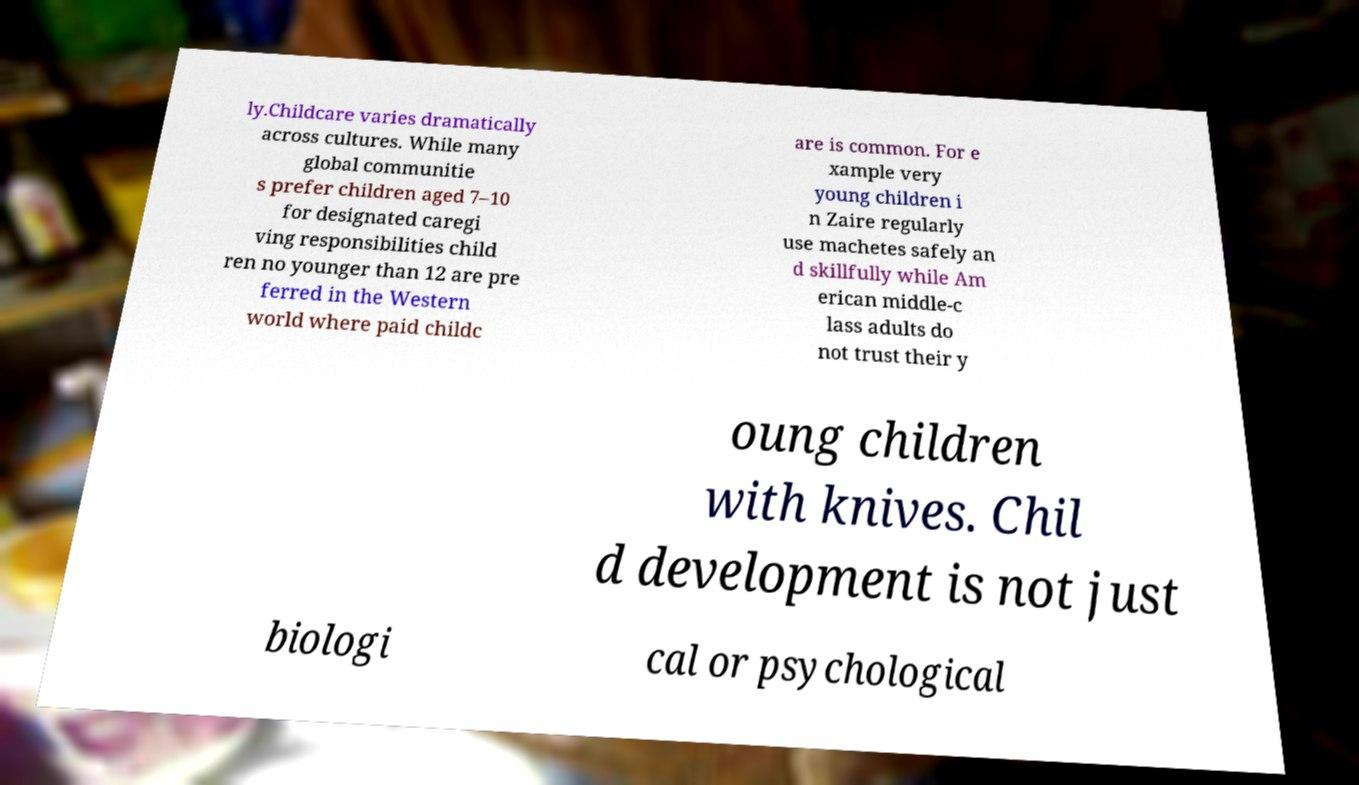Could you assist in decoding the text presented in this image and type it out clearly? ly.Childcare varies dramatically across cultures. While many global communitie s prefer children aged 7–10 for designated caregi ving responsibilities child ren no younger than 12 are pre ferred in the Western world where paid childc are is common. For e xample very young children i n Zaire regularly use machetes safely an d skillfully while Am erican middle-c lass adults do not trust their y oung children with knives. Chil d development is not just biologi cal or psychological 